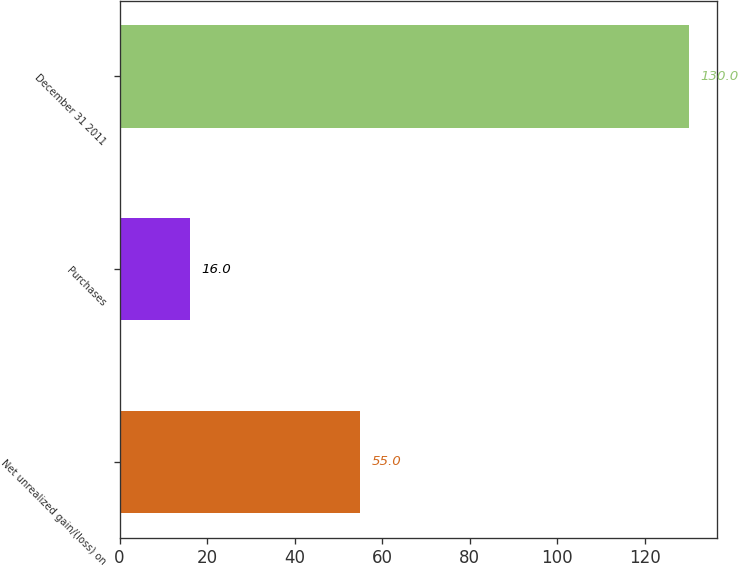Convert chart. <chart><loc_0><loc_0><loc_500><loc_500><bar_chart><fcel>Net unrealized gain/(loss) on<fcel>Purchases<fcel>December 31 2011<nl><fcel>55<fcel>16<fcel>130<nl></chart> 